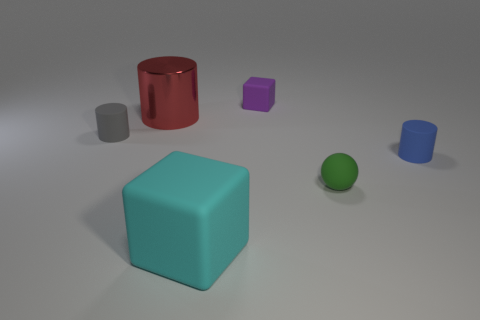Subtract all matte cylinders. How many cylinders are left? 1 Add 2 metallic balls. How many objects exist? 8 Subtract all red cylinders. How many cylinders are left? 2 Subtract all spheres. How many objects are left? 5 Subtract 1 balls. How many balls are left? 0 Subtract all yellow matte objects. Subtract all small purple things. How many objects are left? 5 Add 1 red metal objects. How many red metal objects are left? 2 Add 1 big cyan things. How many big cyan things exist? 2 Subtract 0 brown cylinders. How many objects are left? 6 Subtract all yellow cylinders. Subtract all yellow balls. How many cylinders are left? 3 